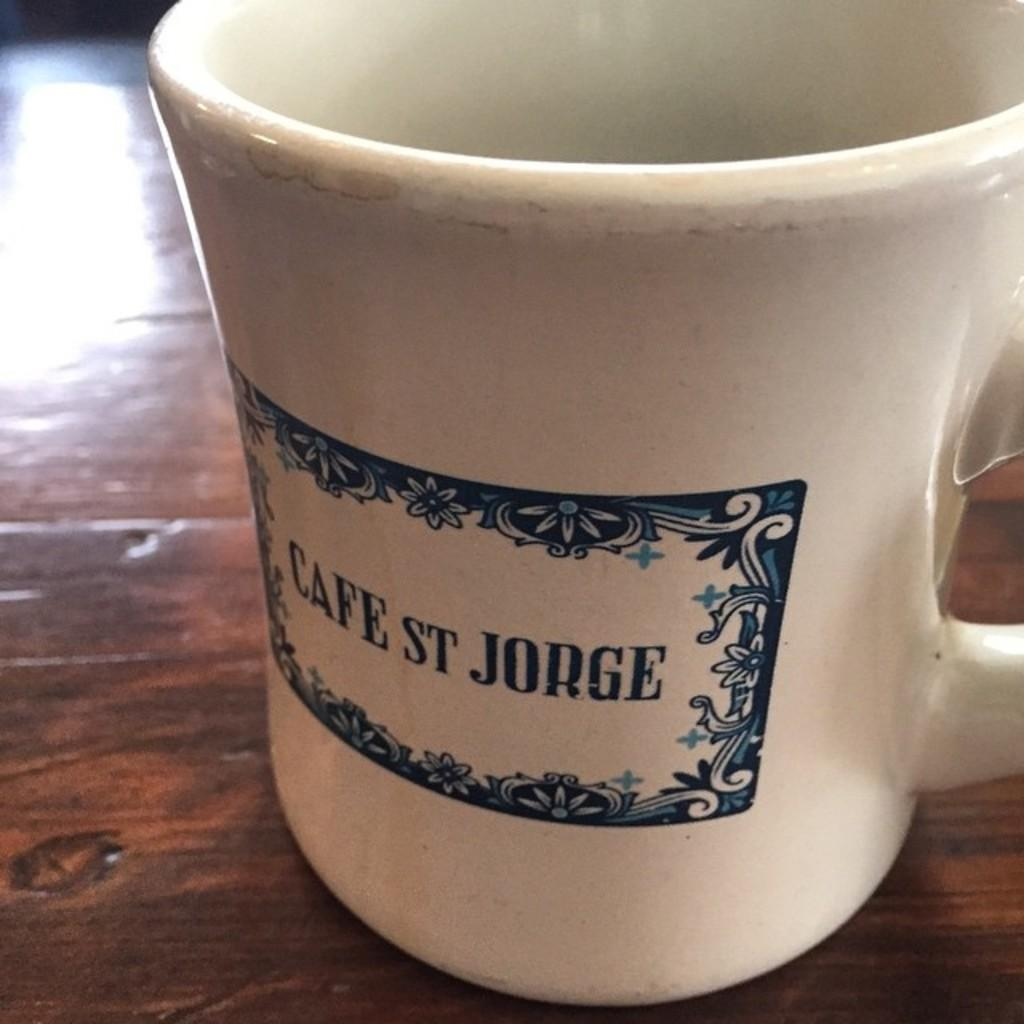<image>
Share a concise interpretation of the image provided. a cup that has cafe st jorge on it 